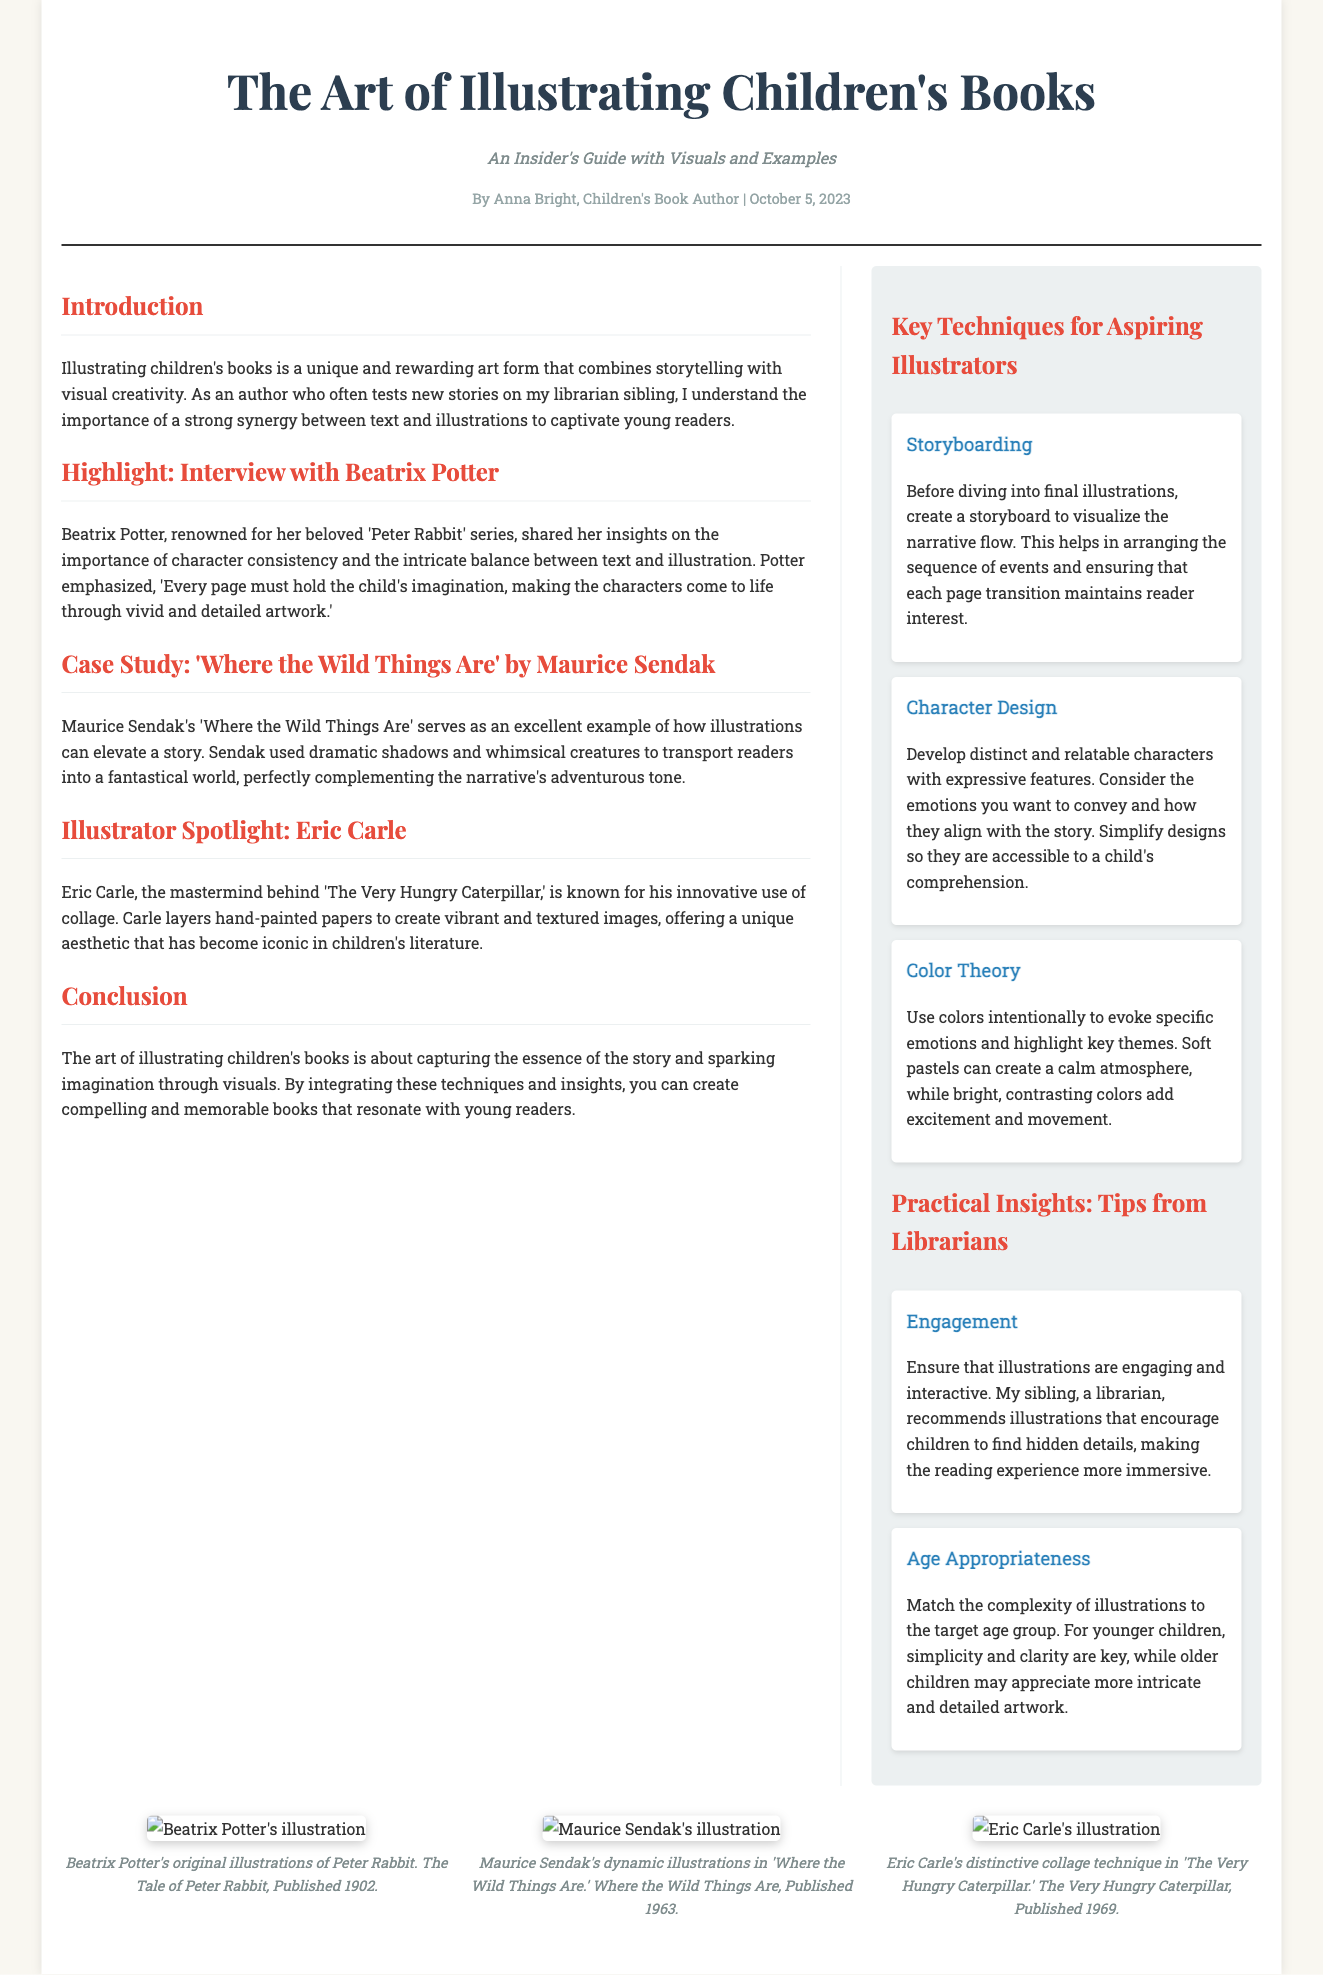What is the title of the article? The title of the article is given prominently at the top, indicating the main topic covered.
Answer: The Art of Illustrating Children's Books Who is the author of the article? The author is noted in the meta section, identifying the individual responsible for the content.
Answer: Anna Bright When was the article published? The publication date is displayed alongside the author's name, providing context for the article's relevance.
Answer: October 5, 2023 What is one key technique mentioned for aspiring illustrators? One of the techniques listed in the sidebar provides insight into a fundamental skill for illustration.
Answer: Storyboarding What character does Beatrix Potter emphasize in her interview? The interview section mentions a specific character associated with Beatrix Potter, highlighting her contributions to children's literature.
Answer: Peter Rabbit What is Eric Carle known for in his illustrations? The spotlight section describes his unique artistic style, which is a hallmark of his work.
Answer: Innovative use of collage What does the article suggest regarding illustrations for younger children? The practical insights section provides guidance on how to tailor illustrations to specific age groups, especially young readers.
Answer: Simplicity and clarity Which book by Maurice Sendak is highlighted as a case study? The case study specifically references an iconic book that demonstrates effective illustration techniques.
Answer: Where the Wild Things Are What emotional effect can color theory have according to the article? The sidebar on color theory discusses how colors can influence feelings and themes within a narrative.
Answer: Evoke specific emotions 